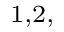Convert formula to latex. <formula><loc_0><loc_0><loc_500><loc_500>^ { 1 , 2 , }</formula> 